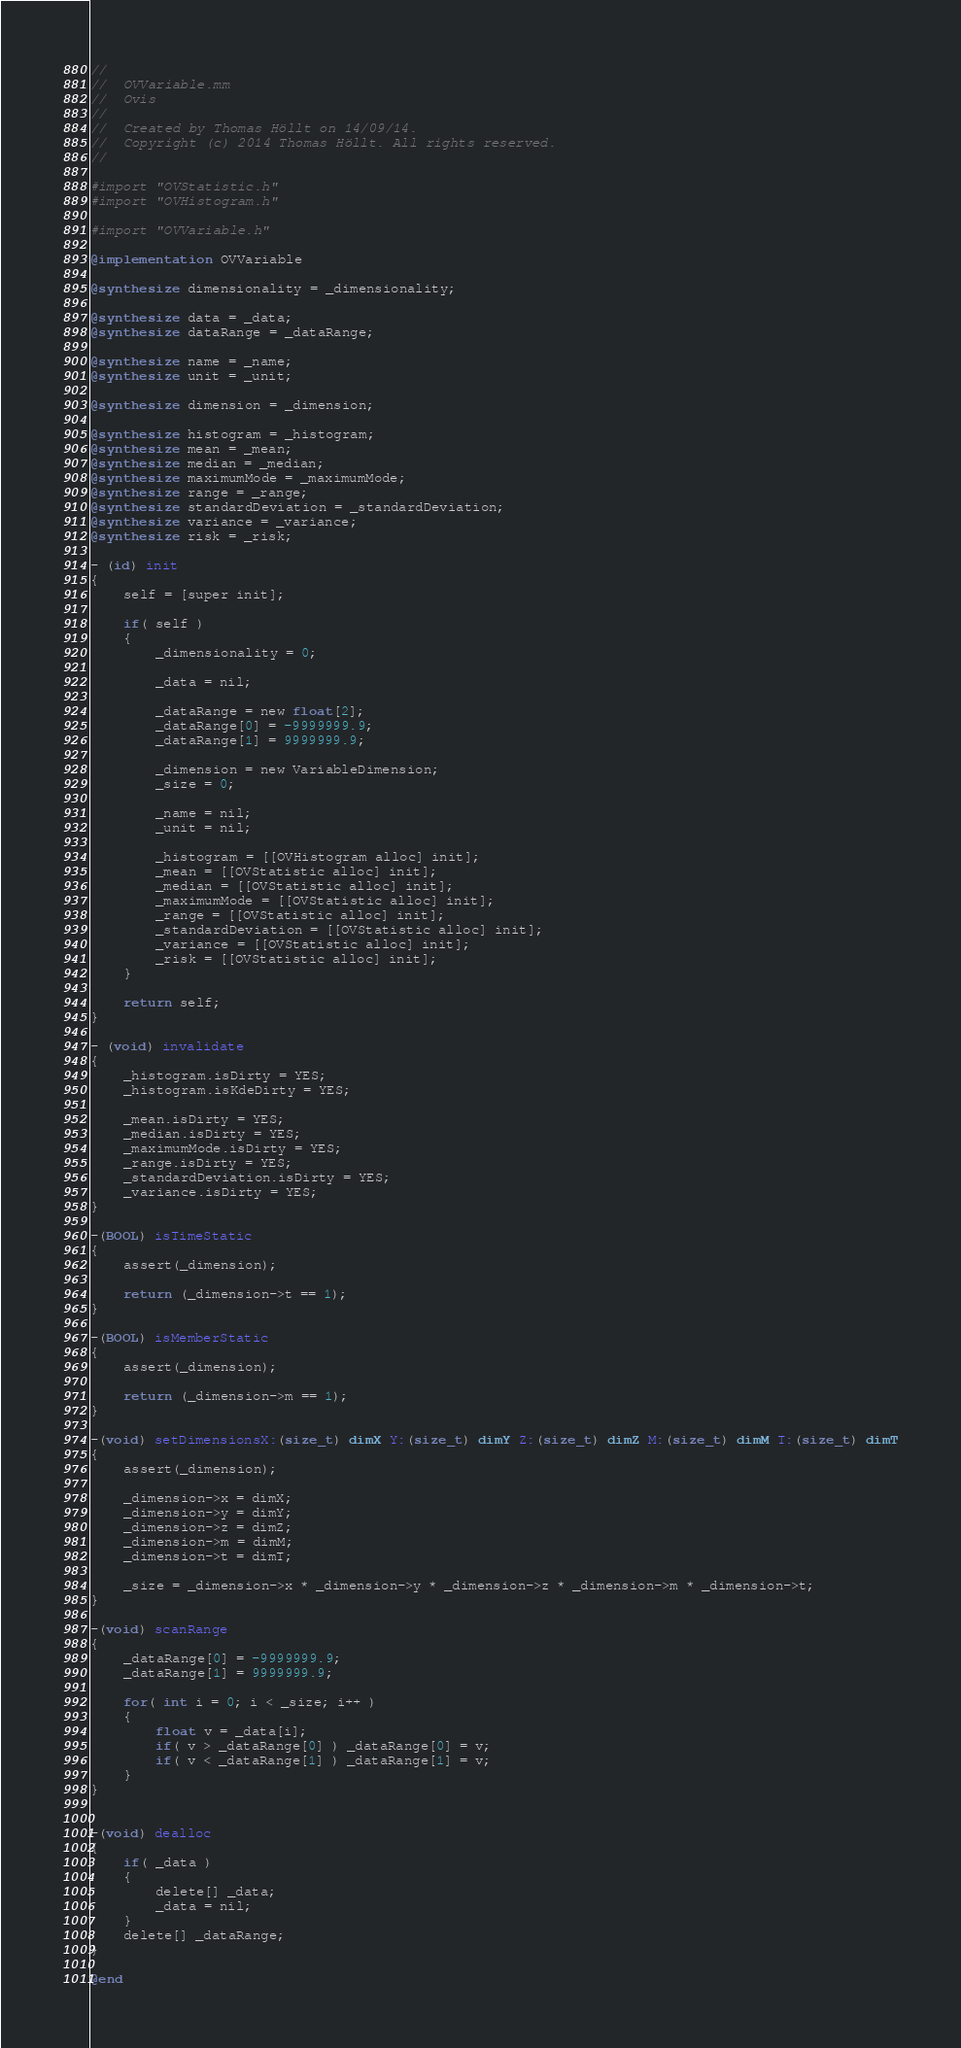<code> <loc_0><loc_0><loc_500><loc_500><_ObjectiveC_>//
//  OVVariable.mm
//  Ovis
//
//  Created by Thomas Höllt on 14/09/14.
//  Copyright (c) 2014 Thomas Höllt. All rights reserved.
//

#import "OVStatistic.h"
#import "OVHistogram.h"

#import "OVVariable.h"

@implementation OVVariable

@synthesize dimensionality = _dimensionality;

@synthesize data = _data;
@synthesize dataRange = _dataRange;

@synthesize name = _name;
@synthesize unit = _unit;

@synthesize dimension = _dimension;

@synthesize histogram = _histogram;
@synthesize mean = _mean;
@synthesize median = _median;
@synthesize maximumMode = _maximumMode;
@synthesize range = _range;
@synthesize standardDeviation = _standardDeviation;
@synthesize variance = _variance;
@synthesize risk = _risk;

- (id) init
{
	self = [super init];
	
	if( self )
    {
        _dimensionality = 0;
        
        _data = nil;
        
        _dataRange = new float[2];
        _dataRange[0] = -9999999.9;
        _dataRange[1] = 9999999.9;
        
        _dimension = new VariableDimension;
        _size = 0;
        
        _name = nil;
        _unit = nil;

        _histogram = [[OVHistogram alloc] init];
        _mean = [[OVStatistic alloc] init];
        _median = [[OVStatistic alloc] init];
        _maximumMode = [[OVStatistic alloc] init];
        _range = [[OVStatistic alloc] init];
        _standardDeviation = [[OVStatistic alloc] init];
        _variance = [[OVStatistic alloc] init];
        _risk = [[OVStatistic alloc] init];
    }
    
    return self;
}

- (void) invalidate
{
    _histogram.isDirty = YES;
    _histogram.isKdeDirty = YES;
    
    _mean.isDirty = YES;
    _median.isDirty = YES;
    _maximumMode.isDirty = YES;
    _range.isDirty = YES;
    _standardDeviation.isDirty = YES;
    _variance.isDirty = YES;
}

-(BOOL) isTimeStatic
{
    assert(_dimension);
    
    return (_dimension->t == 1);
}

-(BOOL) isMemberStatic
{
    assert(_dimension);
    
    return (_dimension->m == 1);
}

-(void) setDimensionsX:(size_t) dimX Y:(size_t) dimY Z:(size_t) dimZ M:(size_t) dimM T:(size_t) dimT
{
    assert(_dimension);
    
    _dimension->x = dimX;
    _dimension->y = dimY;
    _dimension->z = dimZ;
    _dimension->m = dimM;
    _dimension->t = dimT;
    
    _size = _dimension->x * _dimension->y * _dimension->z * _dimension->m * _dimension->t;
}

-(void) scanRange
{
    _dataRange[0] = -9999999.9;
    _dataRange[1] = 9999999.9;
    
    for( int i = 0; i < _size; i++ )
    {
        float v = _data[i];
        if( v > _dataRange[0] ) _dataRange[0] = v;
        if( v < _dataRange[1] ) _dataRange[1] = v;
    }
}


-(void) dealloc
{
    if( _data )
    {
        delete[] _data;
        _data = nil;
    }
    delete[] _dataRange;
}

@end
</code> 